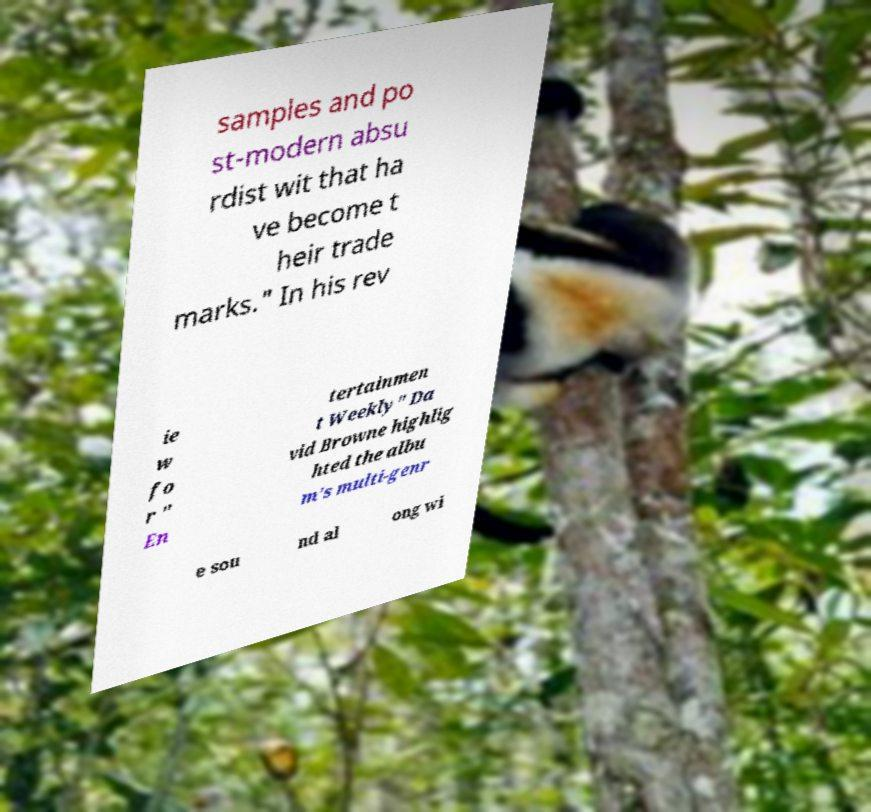There's text embedded in this image that I need extracted. Can you transcribe it verbatim? samples and po st-modern absu rdist wit that ha ve become t heir trade marks." In his rev ie w fo r " En tertainmen t Weekly" Da vid Browne highlig hted the albu m's multi-genr e sou nd al ong wi 